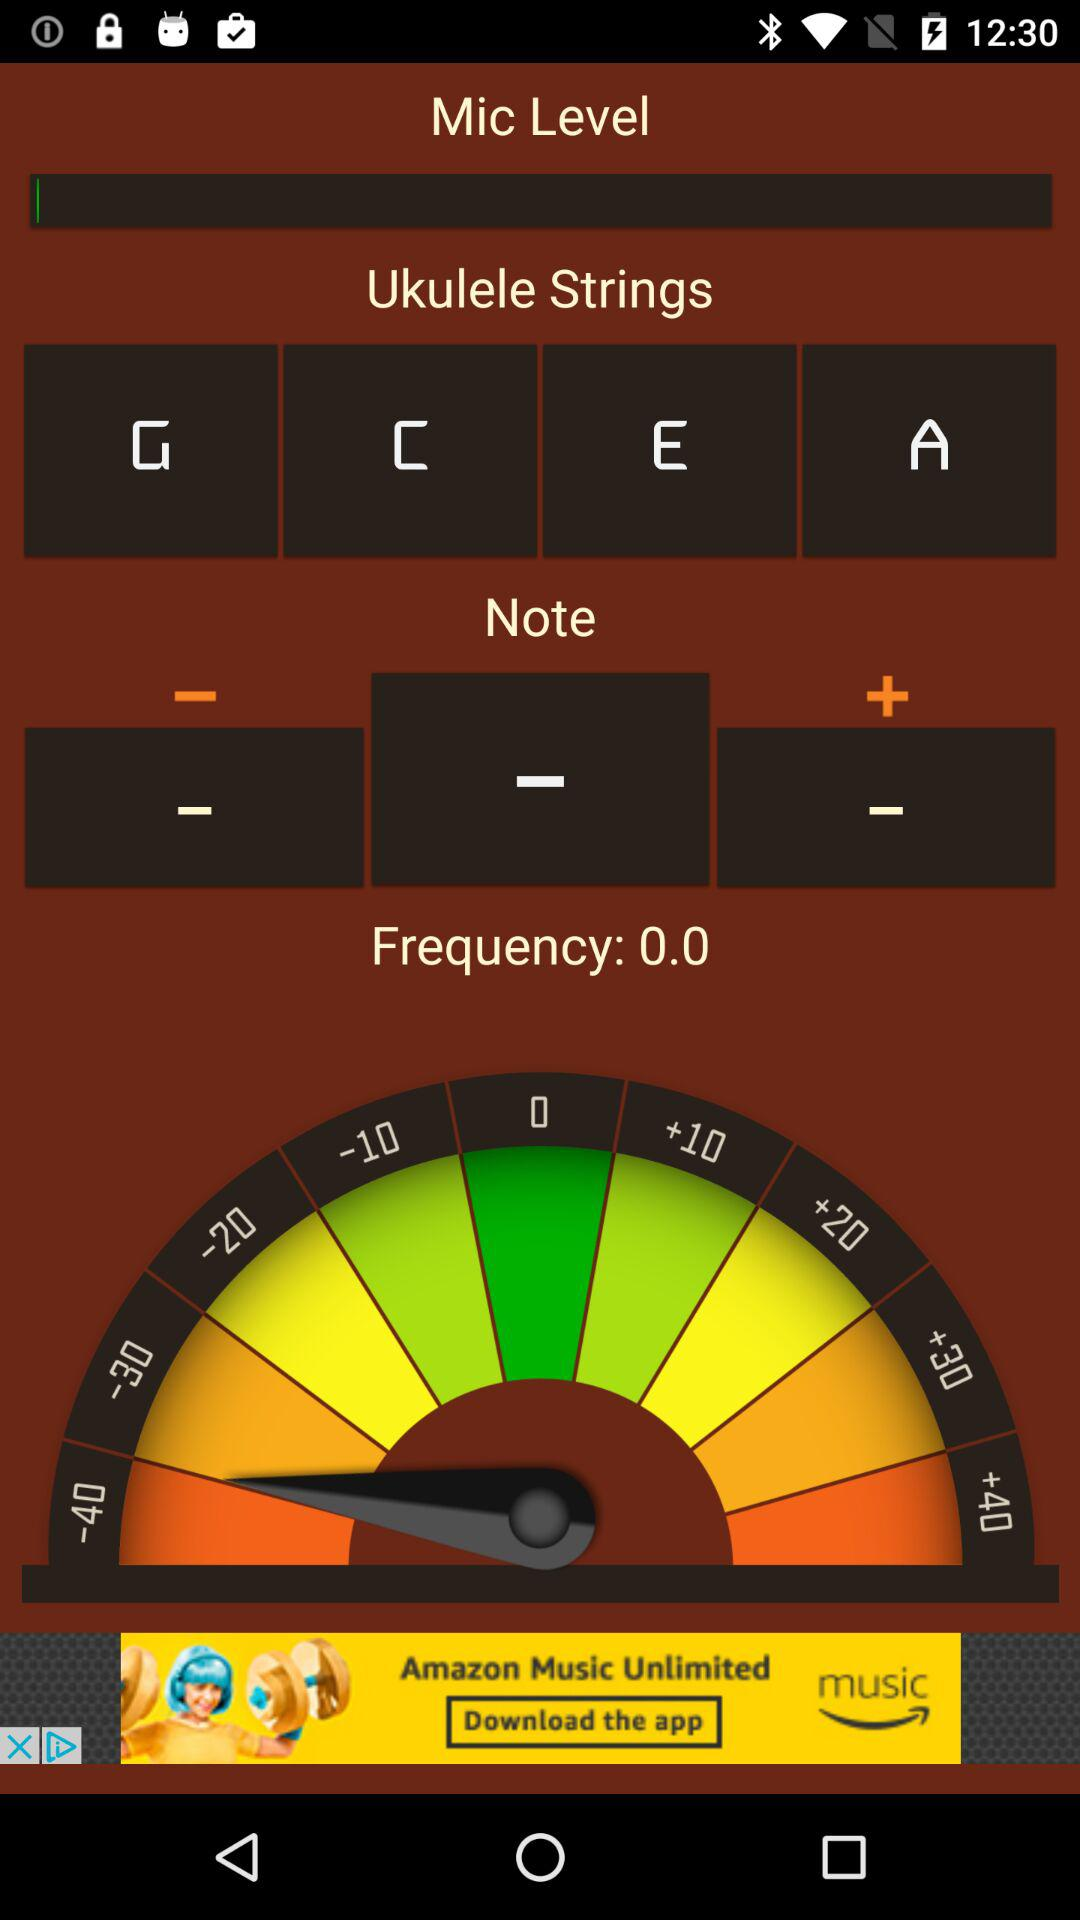What is the frequency of the note currently selected?
Answer the question using a single word or phrase. 0.0 